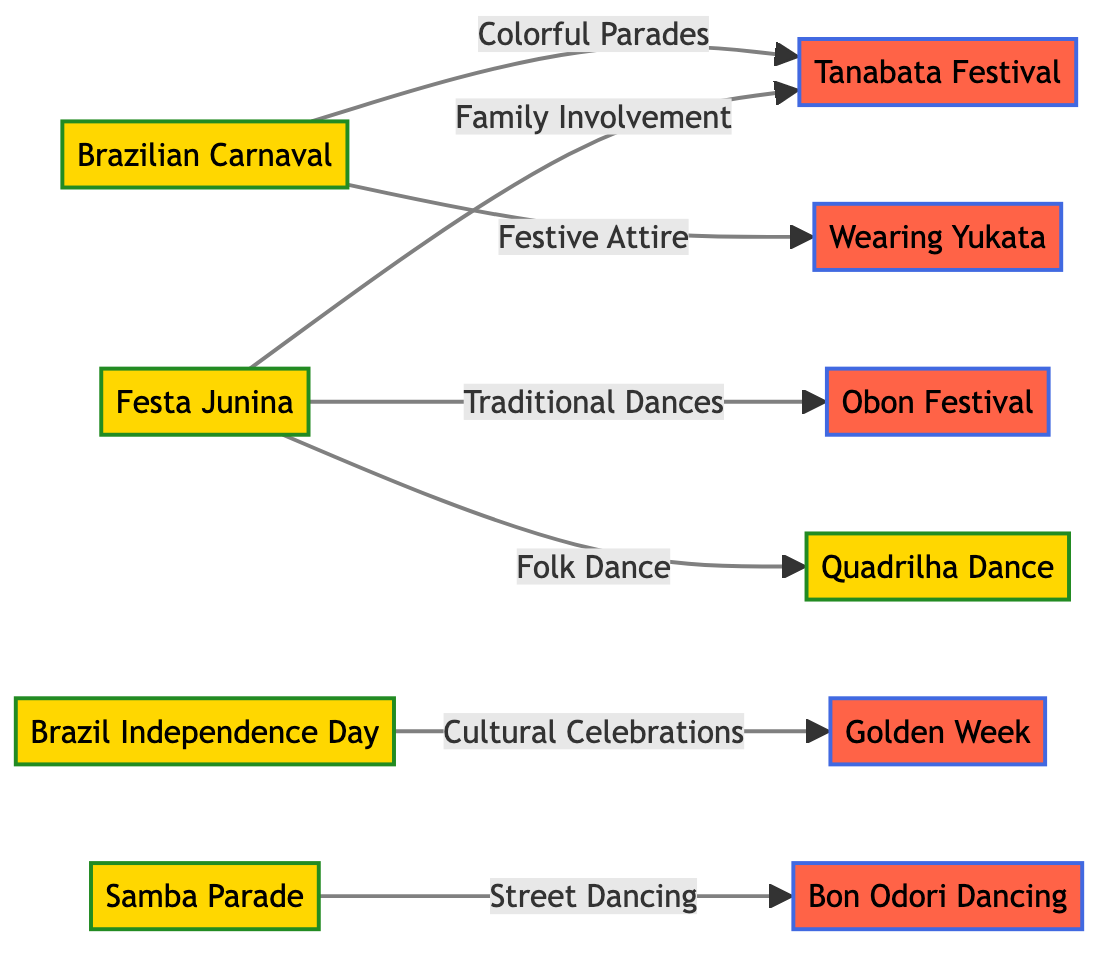What is the relationship between Brazilian Carnaval and Tanabata? The diagram shows an edge labeled "Colorful Parades" connecting Brazilian Carnaval to Tanabata. This indicates that there is a relationship between these two nodes focusing on vibrant parades.
Answer: Colorful Parades How many Brazilian cultural events are listed in the diagram? By counting the nodes labeled with Brazilian cultural events, there are five events: Brazilian Carnaval, Festa Junina, Brazil Independence Day, Samba Parade, and Quadrilha Dance.
Answer: 5 What type of dance is connected to the Obon Festival in the diagram? The diagram indicates that Festa Junina is linked to Obon through a labeled edge "Traditional Dances," which specifies that this type of dance connects the two cultural events.
Answer: Traditional Dances Which Japanese holiday is associated with family involvement from Brazilian culture? The edge from Festa Junina to Tanabata is labeled "Family Involvement," indicating that Tanabata is the Japanese holiday related to family participation in Brazilian culture.
Answer: Tanabata What is the total number of edges in the diagram? Counting the lines connecting the nodes, there are seven edges shown in the diagram that represent the relationships between different events and holidays.
Answer: 7 Which Brazilian event is associated with wearing Yukata? The edge from Brazilian Carnaval to Yukata is labeled "Festive Attire," showing that this Brazilian event relates to the Japanese custom of wearing Yukata.
Answer: Festive Attire How many connections does Festa Junina have in the diagram? By examining the edges connected to Festa Junina, there are three edges leading to Obon, Tanabata, and Quadrilha Dance, indicating its multiple connections in the diagram.
Answer: 3 What type of dancing does Samba Parade connect to in the Japanese culture? The diagram displays an edge labeled "Street Dancing" that links Samba Parade to Bon Odori, which represents a type of dancing in Japanese culture associated with this Brazilian event.
Answer: Street Dancing Which Brazilian event shares a connection with Golden Week? The edge from Brazil Independence Day to Golden Week is labeled "Cultural Celebrations," indicating that Brazil Independence Day is the event that connects to Golden Week in the diagram.
Answer: Cultural Celebrations 